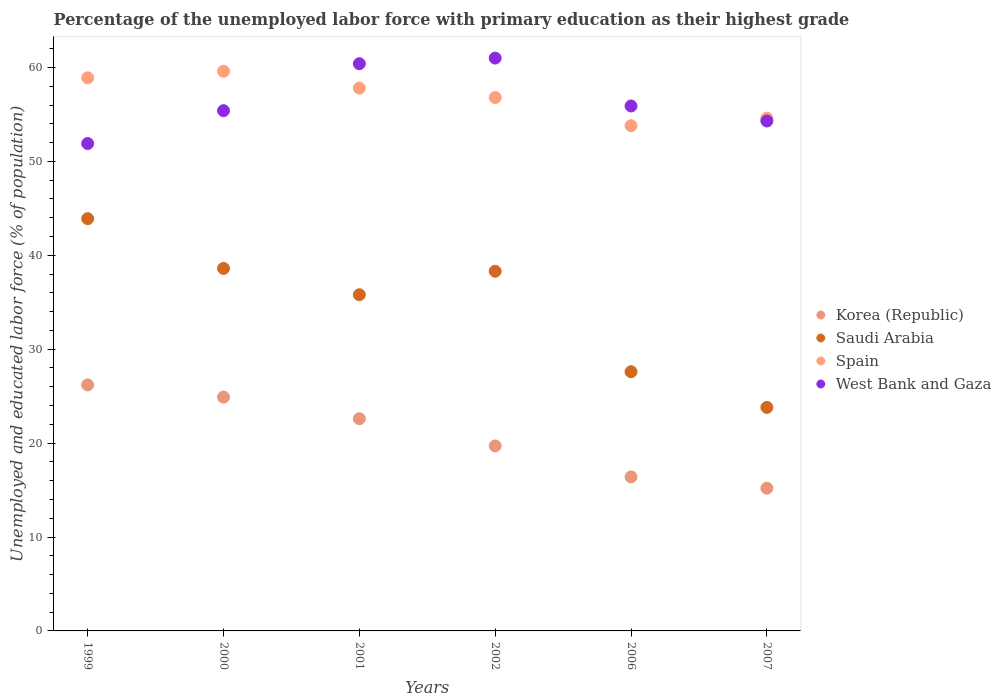Is the number of dotlines equal to the number of legend labels?
Make the answer very short. Yes. What is the percentage of the unemployed labor force with primary education in West Bank and Gaza in 1999?
Provide a short and direct response. 51.9. Across all years, what is the maximum percentage of the unemployed labor force with primary education in Korea (Republic)?
Ensure brevity in your answer.  26.2. Across all years, what is the minimum percentage of the unemployed labor force with primary education in Korea (Republic)?
Ensure brevity in your answer.  15.2. In which year was the percentage of the unemployed labor force with primary education in Korea (Republic) maximum?
Offer a terse response. 1999. What is the total percentage of the unemployed labor force with primary education in Korea (Republic) in the graph?
Offer a terse response. 125. What is the difference between the percentage of the unemployed labor force with primary education in West Bank and Gaza in 1999 and that in 2006?
Your response must be concise. -4. What is the difference between the percentage of the unemployed labor force with primary education in Korea (Republic) in 1999 and the percentage of the unemployed labor force with primary education in Spain in 2000?
Your answer should be very brief. -33.4. What is the average percentage of the unemployed labor force with primary education in West Bank and Gaza per year?
Make the answer very short. 56.48. In the year 2001, what is the difference between the percentage of the unemployed labor force with primary education in Saudi Arabia and percentage of the unemployed labor force with primary education in Korea (Republic)?
Provide a succinct answer. 13.2. In how many years, is the percentage of the unemployed labor force with primary education in West Bank and Gaza greater than 26 %?
Offer a very short reply. 6. What is the ratio of the percentage of the unemployed labor force with primary education in Spain in 1999 to that in 2001?
Keep it short and to the point. 1.02. What is the difference between the highest and the second highest percentage of the unemployed labor force with primary education in Korea (Republic)?
Offer a terse response. 1.3. What is the difference between the highest and the lowest percentage of the unemployed labor force with primary education in Korea (Republic)?
Offer a terse response. 11. In how many years, is the percentage of the unemployed labor force with primary education in West Bank and Gaza greater than the average percentage of the unemployed labor force with primary education in West Bank and Gaza taken over all years?
Provide a short and direct response. 2. Is it the case that in every year, the sum of the percentage of the unemployed labor force with primary education in Korea (Republic) and percentage of the unemployed labor force with primary education in Spain  is greater than the sum of percentage of the unemployed labor force with primary education in Saudi Arabia and percentage of the unemployed labor force with primary education in West Bank and Gaza?
Your answer should be compact. Yes. Does the percentage of the unemployed labor force with primary education in West Bank and Gaza monotonically increase over the years?
Your answer should be compact. No. Does the graph contain any zero values?
Offer a very short reply. No. What is the title of the graph?
Give a very brief answer. Percentage of the unemployed labor force with primary education as their highest grade. Does "Central Europe" appear as one of the legend labels in the graph?
Make the answer very short. No. What is the label or title of the X-axis?
Offer a terse response. Years. What is the label or title of the Y-axis?
Offer a very short reply. Unemployed and educated labor force (% of population). What is the Unemployed and educated labor force (% of population) of Korea (Republic) in 1999?
Provide a succinct answer. 26.2. What is the Unemployed and educated labor force (% of population) in Saudi Arabia in 1999?
Give a very brief answer. 43.9. What is the Unemployed and educated labor force (% of population) of Spain in 1999?
Offer a very short reply. 58.9. What is the Unemployed and educated labor force (% of population) of West Bank and Gaza in 1999?
Provide a short and direct response. 51.9. What is the Unemployed and educated labor force (% of population) in Korea (Republic) in 2000?
Offer a terse response. 24.9. What is the Unemployed and educated labor force (% of population) of Saudi Arabia in 2000?
Your response must be concise. 38.6. What is the Unemployed and educated labor force (% of population) in Spain in 2000?
Offer a very short reply. 59.6. What is the Unemployed and educated labor force (% of population) of West Bank and Gaza in 2000?
Keep it short and to the point. 55.4. What is the Unemployed and educated labor force (% of population) of Korea (Republic) in 2001?
Your answer should be compact. 22.6. What is the Unemployed and educated labor force (% of population) of Saudi Arabia in 2001?
Provide a succinct answer. 35.8. What is the Unemployed and educated labor force (% of population) of Spain in 2001?
Ensure brevity in your answer.  57.8. What is the Unemployed and educated labor force (% of population) of West Bank and Gaza in 2001?
Give a very brief answer. 60.4. What is the Unemployed and educated labor force (% of population) in Korea (Republic) in 2002?
Offer a very short reply. 19.7. What is the Unemployed and educated labor force (% of population) in Saudi Arabia in 2002?
Keep it short and to the point. 38.3. What is the Unemployed and educated labor force (% of population) in Spain in 2002?
Provide a succinct answer. 56.8. What is the Unemployed and educated labor force (% of population) in Korea (Republic) in 2006?
Make the answer very short. 16.4. What is the Unemployed and educated labor force (% of population) of Saudi Arabia in 2006?
Offer a terse response. 27.6. What is the Unemployed and educated labor force (% of population) in Spain in 2006?
Provide a succinct answer. 53.8. What is the Unemployed and educated labor force (% of population) in West Bank and Gaza in 2006?
Your answer should be compact. 55.9. What is the Unemployed and educated labor force (% of population) in Korea (Republic) in 2007?
Offer a very short reply. 15.2. What is the Unemployed and educated labor force (% of population) of Saudi Arabia in 2007?
Offer a terse response. 23.8. What is the Unemployed and educated labor force (% of population) in Spain in 2007?
Ensure brevity in your answer.  54.6. What is the Unemployed and educated labor force (% of population) in West Bank and Gaza in 2007?
Offer a very short reply. 54.3. Across all years, what is the maximum Unemployed and educated labor force (% of population) in Korea (Republic)?
Your answer should be compact. 26.2. Across all years, what is the maximum Unemployed and educated labor force (% of population) in Saudi Arabia?
Provide a succinct answer. 43.9. Across all years, what is the maximum Unemployed and educated labor force (% of population) of Spain?
Make the answer very short. 59.6. Across all years, what is the minimum Unemployed and educated labor force (% of population) in Korea (Republic)?
Keep it short and to the point. 15.2. Across all years, what is the minimum Unemployed and educated labor force (% of population) in Saudi Arabia?
Ensure brevity in your answer.  23.8. Across all years, what is the minimum Unemployed and educated labor force (% of population) in Spain?
Your response must be concise. 53.8. Across all years, what is the minimum Unemployed and educated labor force (% of population) of West Bank and Gaza?
Your answer should be compact. 51.9. What is the total Unemployed and educated labor force (% of population) in Korea (Republic) in the graph?
Provide a succinct answer. 125. What is the total Unemployed and educated labor force (% of population) of Saudi Arabia in the graph?
Provide a short and direct response. 208. What is the total Unemployed and educated labor force (% of population) in Spain in the graph?
Provide a succinct answer. 341.5. What is the total Unemployed and educated labor force (% of population) of West Bank and Gaza in the graph?
Your answer should be very brief. 338.9. What is the difference between the Unemployed and educated labor force (% of population) in Spain in 1999 and that in 2000?
Keep it short and to the point. -0.7. What is the difference between the Unemployed and educated labor force (% of population) of Korea (Republic) in 1999 and that in 2001?
Provide a succinct answer. 3.6. What is the difference between the Unemployed and educated labor force (% of population) of Saudi Arabia in 1999 and that in 2001?
Provide a succinct answer. 8.1. What is the difference between the Unemployed and educated labor force (% of population) of Spain in 1999 and that in 2001?
Your response must be concise. 1.1. What is the difference between the Unemployed and educated labor force (% of population) of West Bank and Gaza in 1999 and that in 2002?
Your answer should be very brief. -9.1. What is the difference between the Unemployed and educated labor force (% of population) of West Bank and Gaza in 1999 and that in 2006?
Give a very brief answer. -4. What is the difference between the Unemployed and educated labor force (% of population) in Korea (Republic) in 1999 and that in 2007?
Your response must be concise. 11. What is the difference between the Unemployed and educated labor force (% of population) of Saudi Arabia in 1999 and that in 2007?
Offer a terse response. 20.1. What is the difference between the Unemployed and educated labor force (% of population) in West Bank and Gaza in 2000 and that in 2001?
Give a very brief answer. -5. What is the difference between the Unemployed and educated labor force (% of population) of Korea (Republic) in 2000 and that in 2002?
Ensure brevity in your answer.  5.2. What is the difference between the Unemployed and educated labor force (% of population) of Saudi Arabia in 2000 and that in 2002?
Your answer should be very brief. 0.3. What is the difference between the Unemployed and educated labor force (% of population) of Spain in 2000 and that in 2006?
Your response must be concise. 5.8. What is the difference between the Unemployed and educated labor force (% of population) of Korea (Republic) in 2000 and that in 2007?
Your answer should be very brief. 9.7. What is the difference between the Unemployed and educated labor force (% of population) of West Bank and Gaza in 2000 and that in 2007?
Give a very brief answer. 1.1. What is the difference between the Unemployed and educated labor force (% of population) in Korea (Republic) in 2001 and that in 2002?
Make the answer very short. 2.9. What is the difference between the Unemployed and educated labor force (% of population) in Saudi Arabia in 2001 and that in 2002?
Your answer should be compact. -2.5. What is the difference between the Unemployed and educated labor force (% of population) in Spain in 2001 and that in 2002?
Your answer should be compact. 1. What is the difference between the Unemployed and educated labor force (% of population) of Korea (Republic) in 2001 and that in 2006?
Ensure brevity in your answer.  6.2. What is the difference between the Unemployed and educated labor force (% of population) in Spain in 2001 and that in 2006?
Your answer should be compact. 4. What is the difference between the Unemployed and educated labor force (% of population) in Saudi Arabia in 2001 and that in 2007?
Give a very brief answer. 12. What is the difference between the Unemployed and educated labor force (% of population) of Spain in 2001 and that in 2007?
Ensure brevity in your answer.  3.2. What is the difference between the Unemployed and educated labor force (% of population) of West Bank and Gaza in 2001 and that in 2007?
Your answer should be very brief. 6.1. What is the difference between the Unemployed and educated labor force (% of population) in Korea (Republic) in 2002 and that in 2006?
Provide a short and direct response. 3.3. What is the difference between the Unemployed and educated labor force (% of population) of Saudi Arabia in 2002 and that in 2006?
Offer a very short reply. 10.7. What is the difference between the Unemployed and educated labor force (% of population) in West Bank and Gaza in 2002 and that in 2006?
Your answer should be very brief. 5.1. What is the difference between the Unemployed and educated labor force (% of population) in Korea (Republic) in 2002 and that in 2007?
Provide a short and direct response. 4.5. What is the difference between the Unemployed and educated labor force (% of population) of West Bank and Gaza in 2002 and that in 2007?
Your answer should be very brief. 6.7. What is the difference between the Unemployed and educated labor force (% of population) in Korea (Republic) in 2006 and that in 2007?
Offer a very short reply. 1.2. What is the difference between the Unemployed and educated labor force (% of population) in Spain in 2006 and that in 2007?
Offer a terse response. -0.8. What is the difference between the Unemployed and educated labor force (% of population) of Korea (Republic) in 1999 and the Unemployed and educated labor force (% of population) of Spain in 2000?
Your response must be concise. -33.4. What is the difference between the Unemployed and educated labor force (% of population) of Korea (Republic) in 1999 and the Unemployed and educated labor force (% of population) of West Bank and Gaza in 2000?
Your answer should be very brief. -29.2. What is the difference between the Unemployed and educated labor force (% of population) of Saudi Arabia in 1999 and the Unemployed and educated labor force (% of population) of Spain in 2000?
Give a very brief answer. -15.7. What is the difference between the Unemployed and educated labor force (% of population) in Korea (Republic) in 1999 and the Unemployed and educated labor force (% of population) in Saudi Arabia in 2001?
Keep it short and to the point. -9.6. What is the difference between the Unemployed and educated labor force (% of population) of Korea (Republic) in 1999 and the Unemployed and educated labor force (% of population) of Spain in 2001?
Give a very brief answer. -31.6. What is the difference between the Unemployed and educated labor force (% of population) in Korea (Republic) in 1999 and the Unemployed and educated labor force (% of population) in West Bank and Gaza in 2001?
Provide a short and direct response. -34.2. What is the difference between the Unemployed and educated labor force (% of population) in Saudi Arabia in 1999 and the Unemployed and educated labor force (% of population) in Spain in 2001?
Provide a succinct answer. -13.9. What is the difference between the Unemployed and educated labor force (% of population) in Saudi Arabia in 1999 and the Unemployed and educated labor force (% of population) in West Bank and Gaza in 2001?
Your response must be concise. -16.5. What is the difference between the Unemployed and educated labor force (% of population) of Spain in 1999 and the Unemployed and educated labor force (% of population) of West Bank and Gaza in 2001?
Provide a short and direct response. -1.5. What is the difference between the Unemployed and educated labor force (% of population) in Korea (Republic) in 1999 and the Unemployed and educated labor force (% of population) in Spain in 2002?
Offer a very short reply. -30.6. What is the difference between the Unemployed and educated labor force (% of population) of Korea (Republic) in 1999 and the Unemployed and educated labor force (% of population) of West Bank and Gaza in 2002?
Offer a terse response. -34.8. What is the difference between the Unemployed and educated labor force (% of population) in Saudi Arabia in 1999 and the Unemployed and educated labor force (% of population) in West Bank and Gaza in 2002?
Your answer should be compact. -17.1. What is the difference between the Unemployed and educated labor force (% of population) in Korea (Republic) in 1999 and the Unemployed and educated labor force (% of population) in Saudi Arabia in 2006?
Your answer should be compact. -1.4. What is the difference between the Unemployed and educated labor force (% of population) in Korea (Republic) in 1999 and the Unemployed and educated labor force (% of population) in Spain in 2006?
Offer a terse response. -27.6. What is the difference between the Unemployed and educated labor force (% of population) in Korea (Republic) in 1999 and the Unemployed and educated labor force (% of population) in West Bank and Gaza in 2006?
Keep it short and to the point. -29.7. What is the difference between the Unemployed and educated labor force (% of population) of Saudi Arabia in 1999 and the Unemployed and educated labor force (% of population) of Spain in 2006?
Give a very brief answer. -9.9. What is the difference between the Unemployed and educated labor force (% of population) in Saudi Arabia in 1999 and the Unemployed and educated labor force (% of population) in West Bank and Gaza in 2006?
Your answer should be compact. -12. What is the difference between the Unemployed and educated labor force (% of population) of Spain in 1999 and the Unemployed and educated labor force (% of population) of West Bank and Gaza in 2006?
Your answer should be compact. 3. What is the difference between the Unemployed and educated labor force (% of population) in Korea (Republic) in 1999 and the Unemployed and educated labor force (% of population) in Saudi Arabia in 2007?
Ensure brevity in your answer.  2.4. What is the difference between the Unemployed and educated labor force (% of population) of Korea (Republic) in 1999 and the Unemployed and educated labor force (% of population) of Spain in 2007?
Keep it short and to the point. -28.4. What is the difference between the Unemployed and educated labor force (% of population) of Korea (Republic) in 1999 and the Unemployed and educated labor force (% of population) of West Bank and Gaza in 2007?
Your response must be concise. -28.1. What is the difference between the Unemployed and educated labor force (% of population) in Saudi Arabia in 1999 and the Unemployed and educated labor force (% of population) in West Bank and Gaza in 2007?
Ensure brevity in your answer.  -10.4. What is the difference between the Unemployed and educated labor force (% of population) of Korea (Republic) in 2000 and the Unemployed and educated labor force (% of population) of Spain in 2001?
Make the answer very short. -32.9. What is the difference between the Unemployed and educated labor force (% of population) of Korea (Republic) in 2000 and the Unemployed and educated labor force (% of population) of West Bank and Gaza in 2001?
Keep it short and to the point. -35.5. What is the difference between the Unemployed and educated labor force (% of population) in Saudi Arabia in 2000 and the Unemployed and educated labor force (% of population) in Spain in 2001?
Your answer should be compact. -19.2. What is the difference between the Unemployed and educated labor force (% of population) of Saudi Arabia in 2000 and the Unemployed and educated labor force (% of population) of West Bank and Gaza in 2001?
Keep it short and to the point. -21.8. What is the difference between the Unemployed and educated labor force (% of population) in Korea (Republic) in 2000 and the Unemployed and educated labor force (% of population) in Saudi Arabia in 2002?
Your response must be concise. -13.4. What is the difference between the Unemployed and educated labor force (% of population) of Korea (Republic) in 2000 and the Unemployed and educated labor force (% of population) of Spain in 2002?
Your answer should be very brief. -31.9. What is the difference between the Unemployed and educated labor force (% of population) in Korea (Republic) in 2000 and the Unemployed and educated labor force (% of population) in West Bank and Gaza in 2002?
Provide a short and direct response. -36.1. What is the difference between the Unemployed and educated labor force (% of population) of Saudi Arabia in 2000 and the Unemployed and educated labor force (% of population) of Spain in 2002?
Make the answer very short. -18.2. What is the difference between the Unemployed and educated labor force (% of population) in Saudi Arabia in 2000 and the Unemployed and educated labor force (% of population) in West Bank and Gaza in 2002?
Offer a terse response. -22.4. What is the difference between the Unemployed and educated labor force (% of population) of Spain in 2000 and the Unemployed and educated labor force (% of population) of West Bank and Gaza in 2002?
Your answer should be very brief. -1.4. What is the difference between the Unemployed and educated labor force (% of population) of Korea (Republic) in 2000 and the Unemployed and educated labor force (% of population) of Saudi Arabia in 2006?
Make the answer very short. -2.7. What is the difference between the Unemployed and educated labor force (% of population) of Korea (Republic) in 2000 and the Unemployed and educated labor force (% of population) of Spain in 2006?
Ensure brevity in your answer.  -28.9. What is the difference between the Unemployed and educated labor force (% of population) in Korea (Republic) in 2000 and the Unemployed and educated labor force (% of population) in West Bank and Gaza in 2006?
Give a very brief answer. -31. What is the difference between the Unemployed and educated labor force (% of population) of Saudi Arabia in 2000 and the Unemployed and educated labor force (% of population) of Spain in 2006?
Ensure brevity in your answer.  -15.2. What is the difference between the Unemployed and educated labor force (% of population) of Saudi Arabia in 2000 and the Unemployed and educated labor force (% of population) of West Bank and Gaza in 2006?
Provide a short and direct response. -17.3. What is the difference between the Unemployed and educated labor force (% of population) of Spain in 2000 and the Unemployed and educated labor force (% of population) of West Bank and Gaza in 2006?
Make the answer very short. 3.7. What is the difference between the Unemployed and educated labor force (% of population) in Korea (Republic) in 2000 and the Unemployed and educated labor force (% of population) in Spain in 2007?
Your response must be concise. -29.7. What is the difference between the Unemployed and educated labor force (% of population) of Korea (Republic) in 2000 and the Unemployed and educated labor force (% of population) of West Bank and Gaza in 2007?
Make the answer very short. -29.4. What is the difference between the Unemployed and educated labor force (% of population) in Saudi Arabia in 2000 and the Unemployed and educated labor force (% of population) in Spain in 2007?
Give a very brief answer. -16. What is the difference between the Unemployed and educated labor force (% of population) in Saudi Arabia in 2000 and the Unemployed and educated labor force (% of population) in West Bank and Gaza in 2007?
Provide a short and direct response. -15.7. What is the difference between the Unemployed and educated labor force (% of population) in Korea (Republic) in 2001 and the Unemployed and educated labor force (% of population) in Saudi Arabia in 2002?
Keep it short and to the point. -15.7. What is the difference between the Unemployed and educated labor force (% of population) in Korea (Republic) in 2001 and the Unemployed and educated labor force (% of population) in Spain in 2002?
Ensure brevity in your answer.  -34.2. What is the difference between the Unemployed and educated labor force (% of population) of Korea (Republic) in 2001 and the Unemployed and educated labor force (% of population) of West Bank and Gaza in 2002?
Make the answer very short. -38.4. What is the difference between the Unemployed and educated labor force (% of population) in Saudi Arabia in 2001 and the Unemployed and educated labor force (% of population) in Spain in 2002?
Your response must be concise. -21. What is the difference between the Unemployed and educated labor force (% of population) in Saudi Arabia in 2001 and the Unemployed and educated labor force (% of population) in West Bank and Gaza in 2002?
Your answer should be very brief. -25.2. What is the difference between the Unemployed and educated labor force (% of population) of Spain in 2001 and the Unemployed and educated labor force (% of population) of West Bank and Gaza in 2002?
Your response must be concise. -3.2. What is the difference between the Unemployed and educated labor force (% of population) in Korea (Republic) in 2001 and the Unemployed and educated labor force (% of population) in Saudi Arabia in 2006?
Give a very brief answer. -5. What is the difference between the Unemployed and educated labor force (% of population) of Korea (Republic) in 2001 and the Unemployed and educated labor force (% of population) of Spain in 2006?
Offer a terse response. -31.2. What is the difference between the Unemployed and educated labor force (% of population) in Korea (Republic) in 2001 and the Unemployed and educated labor force (% of population) in West Bank and Gaza in 2006?
Ensure brevity in your answer.  -33.3. What is the difference between the Unemployed and educated labor force (% of population) in Saudi Arabia in 2001 and the Unemployed and educated labor force (% of population) in Spain in 2006?
Ensure brevity in your answer.  -18. What is the difference between the Unemployed and educated labor force (% of population) of Saudi Arabia in 2001 and the Unemployed and educated labor force (% of population) of West Bank and Gaza in 2006?
Give a very brief answer. -20.1. What is the difference between the Unemployed and educated labor force (% of population) in Korea (Republic) in 2001 and the Unemployed and educated labor force (% of population) in Saudi Arabia in 2007?
Your answer should be compact. -1.2. What is the difference between the Unemployed and educated labor force (% of population) of Korea (Republic) in 2001 and the Unemployed and educated labor force (% of population) of Spain in 2007?
Your answer should be very brief. -32. What is the difference between the Unemployed and educated labor force (% of population) of Korea (Republic) in 2001 and the Unemployed and educated labor force (% of population) of West Bank and Gaza in 2007?
Offer a very short reply. -31.7. What is the difference between the Unemployed and educated labor force (% of population) of Saudi Arabia in 2001 and the Unemployed and educated labor force (% of population) of Spain in 2007?
Provide a short and direct response. -18.8. What is the difference between the Unemployed and educated labor force (% of population) of Saudi Arabia in 2001 and the Unemployed and educated labor force (% of population) of West Bank and Gaza in 2007?
Keep it short and to the point. -18.5. What is the difference between the Unemployed and educated labor force (% of population) of Korea (Republic) in 2002 and the Unemployed and educated labor force (% of population) of Spain in 2006?
Offer a terse response. -34.1. What is the difference between the Unemployed and educated labor force (% of population) of Korea (Republic) in 2002 and the Unemployed and educated labor force (% of population) of West Bank and Gaza in 2006?
Your answer should be very brief. -36.2. What is the difference between the Unemployed and educated labor force (% of population) of Saudi Arabia in 2002 and the Unemployed and educated labor force (% of population) of Spain in 2006?
Make the answer very short. -15.5. What is the difference between the Unemployed and educated labor force (% of population) in Saudi Arabia in 2002 and the Unemployed and educated labor force (% of population) in West Bank and Gaza in 2006?
Ensure brevity in your answer.  -17.6. What is the difference between the Unemployed and educated labor force (% of population) of Spain in 2002 and the Unemployed and educated labor force (% of population) of West Bank and Gaza in 2006?
Give a very brief answer. 0.9. What is the difference between the Unemployed and educated labor force (% of population) of Korea (Republic) in 2002 and the Unemployed and educated labor force (% of population) of Saudi Arabia in 2007?
Your response must be concise. -4.1. What is the difference between the Unemployed and educated labor force (% of population) of Korea (Republic) in 2002 and the Unemployed and educated labor force (% of population) of Spain in 2007?
Offer a terse response. -34.9. What is the difference between the Unemployed and educated labor force (% of population) of Korea (Republic) in 2002 and the Unemployed and educated labor force (% of population) of West Bank and Gaza in 2007?
Provide a succinct answer. -34.6. What is the difference between the Unemployed and educated labor force (% of population) in Saudi Arabia in 2002 and the Unemployed and educated labor force (% of population) in Spain in 2007?
Provide a succinct answer. -16.3. What is the difference between the Unemployed and educated labor force (% of population) in Saudi Arabia in 2002 and the Unemployed and educated labor force (% of population) in West Bank and Gaza in 2007?
Ensure brevity in your answer.  -16. What is the difference between the Unemployed and educated labor force (% of population) in Korea (Republic) in 2006 and the Unemployed and educated labor force (% of population) in Saudi Arabia in 2007?
Ensure brevity in your answer.  -7.4. What is the difference between the Unemployed and educated labor force (% of population) in Korea (Republic) in 2006 and the Unemployed and educated labor force (% of population) in Spain in 2007?
Provide a short and direct response. -38.2. What is the difference between the Unemployed and educated labor force (% of population) in Korea (Republic) in 2006 and the Unemployed and educated labor force (% of population) in West Bank and Gaza in 2007?
Provide a short and direct response. -37.9. What is the difference between the Unemployed and educated labor force (% of population) of Saudi Arabia in 2006 and the Unemployed and educated labor force (% of population) of Spain in 2007?
Ensure brevity in your answer.  -27. What is the difference between the Unemployed and educated labor force (% of population) of Saudi Arabia in 2006 and the Unemployed and educated labor force (% of population) of West Bank and Gaza in 2007?
Your answer should be compact. -26.7. What is the difference between the Unemployed and educated labor force (% of population) in Spain in 2006 and the Unemployed and educated labor force (% of population) in West Bank and Gaza in 2007?
Provide a succinct answer. -0.5. What is the average Unemployed and educated labor force (% of population) in Korea (Republic) per year?
Keep it short and to the point. 20.83. What is the average Unemployed and educated labor force (% of population) of Saudi Arabia per year?
Offer a very short reply. 34.67. What is the average Unemployed and educated labor force (% of population) in Spain per year?
Offer a terse response. 56.92. What is the average Unemployed and educated labor force (% of population) in West Bank and Gaza per year?
Your answer should be very brief. 56.48. In the year 1999, what is the difference between the Unemployed and educated labor force (% of population) in Korea (Republic) and Unemployed and educated labor force (% of population) in Saudi Arabia?
Your answer should be very brief. -17.7. In the year 1999, what is the difference between the Unemployed and educated labor force (% of population) in Korea (Republic) and Unemployed and educated labor force (% of population) in Spain?
Your answer should be compact. -32.7. In the year 1999, what is the difference between the Unemployed and educated labor force (% of population) of Korea (Republic) and Unemployed and educated labor force (% of population) of West Bank and Gaza?
Give a very brief answer. -25.7. In the year 1999, what is the difference between the Unemployed and educated labor force (% of population) of Saudi Arabia and Unemployed and educated labor force (% of population) of West Bank and Gaza?
Offer a very short reply. -8. In the year 1999, what is the difference between the Unemployed and educated labor force (% of population) in Spain and Unemployed and educated labor force (% of population) in West Bank and Gaza?
Give a very brief answer. 7. In the year 2000, what is the difference between the Unemployed and educated labor force (% of population) in Korea (Republic) and Unemployed and educated labor force (% of population) in Saudi Arabia?
Your response must be concise. -13.7. In the year 2000, what is the difference between the Unemployed and educated labor force (% of population) in Korea (Republic) and Unemployed and educated labor force (% of population) in Spain?
Keep it short and to the point. -34.7. In the year 2000, what is the difference between the Unemployed and educated labor force (% of population) in Korea (Republic) and Unemployed and educated labor force (% of population) in West Bank and Gaza?
Your answer should be very brief. -30.5. In the year 2000, what is the difference between the Unemployed and educated labor force (% of population) in Saudi Arabia and Unemployed and educated labor force (% of population) in Spain?
Provide a short and direct response. -21. In the year 2000, what is the difference between the Unemployed and educated labor force (% of population) in Saudi Arabia and Unemployed and educated labor force (% of population) in West Bank and Gaza?
Your response must be concise. -16.8. In the year 2001, what is the difference between the Unemployed and educated labor force (% of population) of Korea (Republic) and Unemployed and educated labor force (% of population) of Saudi Arabia?
Provide a short and direct response. -13.2. In the year 2001, what is the difference between the Unemployed and educated labor force (% of population) of Korea (Republic) and Unemployed and educated labor force (% of population) of Spain?
Your answer should be very brief. -35.2. In the year 2001, what is the difference between the Unemployed and educated labor force (% of population) in Korea (Republic) and Unemployed and educated labor force (% of population) in West Bank and Gaza?
Give a very brief answer. -37.8. In the year 2001, what is the difference between the Unemployed and educated labor force (% of population) in Saudi Arabia and Unemployed and educated labor force (% of population) in Spain?
Offer a terse response. -22. In the year 2001, what is the difference between the Unemployed and educated labor force (% of population) of Saudi Arabia and Unemployed and educated labor force (% of population) of West Bank and Gaza?
Keep it short and to the point. -24.6. In the year 2002, what is the difference between the Unemployed and educated labor force (% of population) of Korea (Republic) and Unemployed and educated labor force (% of population) of Saudi Arabia?
Provide a short and direct response. -18.6. In the year 2002, what is the difference between the Unemployed and educated labor force (% of population) of Korea (Republic) and Unemployed and educated labor force (% of population) of Spain?
Your answer should be very brief. -37.1. In the year 2002, what is the difference between the Unemployed and educated labor force (% of population) in Korea (Republic) and Unemployed and educated labor force (% of population) in West Bank and Gaza?
Provide a short and direct response. -41.3. In the year 2002, what is the difference between the Unemployed and educated labor force (% of population) in Saudi Arabia and Unemployed and educated labor force (% of population) in Spain?
Offer a terse response. -18.5. In the year 2002, what is the difference between the Unemployed and educated labor force (% of population) of Saudi Arabia and Unemployed and educated labor force (% of population) of West Bank and Gaza?
Your response must be concise. -22.7. In the year 2006, what is the difference between the Unemployed and educated labor force (% of population) of Korea (Republic) and Unemployed and educated labor force (% of population) of Saudi Arabia?
Make the answer very short. -11.2. In the year 2006, what is the difference between the Unemployed and educated labor force (% of population) of Korea (Republic) and Unemployed and educated labor force (% of population) of Spain?
Your answer should be very brief. -37.4. In the year 2006, what is the difference between the Unemployed and educated labor force (% of population) in Korea (Republic) and Unemployed and educated labor force (% of population) in West Bank and Gaza?
Your answer should be compact. -39.5. In the year 2006, what is the difference between the Unemployed and educated labor force (% of population) of Saudi Arabia and Unemployed and educated labor force (% of population) of Spain?
Provide a succinct answer. -26.2. In the year 2006, what is the difference between the Unemployed and educated labor force (% of population) of Saudi Arabia and Unemployed and educated labor force (% of population) of West Bank and Gaza?
Ensure brevity in your answer.  -28.3. In the year 2006, what is the difference between the Unemployed and educated labor force (% of population) of Spain and Unemployed and educated labor force (% of population) of West Bank and Gaza?
Your response must be concise. -2.1. In the year 2007, what is the difference between the Unemployed and educated labor force (% of population) of Korea (Republic) and Unemployed and educated labor force (% of population) of Spain?
Provide a short and direct response. -39.4. In the year 2007, what is the difference between the Unemployed and educated labor force (% of population) in Korea (Republic) and Unemployed and educated labor force (% of population) in West Bank and Gaza?
Offer a terse response. -39.1. In the year 2007, what is the difference between the Unemployed and educated labor force (% of population) of Saudi Arabia and Unemployed and educated labor force (% of population) of Spain?
Your response must be concise. -30.8. In the year 2007, what is the difference between the Unemployed and educated labor force (% of population) of Saudi Arabia and Unemployed and educated labor force (% of population) of West Bank and Gaza?
Give a very brief answer. -30.5. In the year 2007, what is the difference between the Unemployed and educated labor force (% of population) of Spain and Unemployed and educated labor force (% of population) of West Bank and Gaza?
Offer a very short reply. 0.3. What is the ratio of the Unemployed and educated labor force (% of population) in Korea (Republic) in 1999 to that in 2000?
Keep it short and to the point. 1.05. What is the ratio of the Unemployed and educated labor force (% of population) of Saudi Arabia in 1999 to that in 2000?
Provide a short and direct response. 1.14. What is the ratio of the Unemployed and educated labor force (% of population) in Spain in 1999 to that in 2000?
Provide a short and direct response. 0.99. What is the ratio of the Unemployed and educated labor force (% of population) of West Bank and Gaza in 1999 to that in 2000?
Make the answer very short. 0.94. What is the ratio of the Unemployed and educated labor force (% of population) in Korea (Republic) in 1999 to that in 2001?
Offer a terse response. 1.16. What is the ratio of the Unemployed and educated labor force (% of population) of Saudi Arabia in 1999 to that in 2001?
Provide a short and direct response. 1.23. What is the ratio of the Unemployed and educated labor force (% of population) of Spain in 1999 to that in 2001?
Provide a short and direct response. 1.02. What is the ratio of the Unemployed and educated labor force (% of population) in West Bank and Gaza in 1999 to that in 2001?
Offer a terse response. 0.86. What is the ratio of the Unemployed and educated labor force (% of population) of Korea (Republic) in 1999 to that in 2002?
Your answer should be very brief. 1.33. What is the ratio of the Unemployed and educated labor force (% of population) of Saudi Arabia in 1999 to that in 2002?
Offer a terse response. 1.15. What is the ratio of the Unemployed and educated labor force (% of population) in Spain in 1999 to that in 2002?
Provide a short and direct response. 1.04. What is the ratio of the Unemployed and educated labor force (% of population) in West Bank and Gaza in 1999 to that in 2002?
Provide a short and direct response. 0.85. What is the ratio of the Unemployed and educated labor force (% of population) of Korea (Republic) in 1999 to that in 2006?
Provide a short and direct response. 1.6. What is the ratio of the Unemployed and educated labor force (% of population) in Saudi Arabia in 1999 to that in 2006?
Your answer should be compact. 1.59. What is the ratio of the Unemployed and educated labor force (% of population) in Spain in 1999 to that in 2006?
Make the answer very short. 1.09. What is the ratio of the Unemployed and educated labor force (% of population) of West Bank and Gaza in 1999 to that in 2006?
Offer a very short reply. 0.93. What is the ratio of the Unemployed and educated labor force (% of population) of Korea (Republic) in 1999 to that in 2007?
Provide a short and direct response. 1.72. What is the ratio of the Unemployed and educated labor force (% of population) in Saudi Arabia in 1999 to that in 2007?
Ensure brevity in your answer.  1.84. What is the ratio of the Unemployed and educated labor force (% of population) in Spain in 1999 to that in 2007?
Make the answer very short. 1.08. What is the ratio of the Unemployed and educated labor force (% of population) in West Bank and Gaza in 1999 to that in 2007?
Offer a terse response. 0.96. What is the ratio of the Unemployed and educated labor force (% of population) of Korea (Republic) in 2000 to that in 2001?
Provide a short and direct response. 1.1. What is the ratio of the Unemployed and educated labor force (% of population) in Saudi Arabia in 2000 to that in 2001?
Offer a terse response. 1.08. What is the ratio of the Unemployed and educated labor force (% of population) of Spain in 2000 to that in 2001?
Provide a short and direct response. 1.03. What is the ratio of the Unemployed and educated labor force (% of population) in West Bank and Gaza in 2000 to that in 2001?
Ensure brevity in your answer.  0.92. What is the ratio of the Unemployed and educated labor force (% of population) of Korea (Republic) in 2000 to that in 2002?
Keep it short and to the point. 1.26. What is the ratio of the Unemployed and educated labor force (% of population) in Spain in 2000 to that in 2002?
Your answer should be very brief. 1.05. What is the ratio of the Unemployed and educated labor force (% of population) of West Bank and Gaza in 2000 to that in 2002?
Make the answer very short. 0.91. What is the ratio of the Unemployed and educated labor force (% of population) of Korea (Republic) in 2000 to that in 2006?
Offer a very short reply. 1.52. What is the ratio of the Unemployed and educated labor force (% of population) of Saudi Arabia in 2000 to that in 2006?
Provide a succinct answer. 1.4. What is the ratio of the Unemployed and educated labor force (% of population) in Spain in 2000 to that in 2006?
Give a very brief answer. 1.11. What is the ratio of the Unemployed and educated labor force (% of population) in West Bank and Gaza in 2000 to that in 2006?
Your response must be concise. 0.99. What is the ratio of the Unemployed and educated labor force (% of population) of Korea (Republic) in 2000 to that in 2007?
Keep it short and to the point. 1.64. What is the ratio of the Unemployed and educated labor force (% of population) of Saudi Arabia in 2000 to that in 2007?
Offer a very short reply. 1.62. What is the ratio of the Unemployed and educated labor force (% of population) of Spain in 2000 to that in 2007?
Ensure brevity in your answer.  1.09. What is the ratio of the Unemployed and educated labor force (% of population) in West Bank and Gaza in 2000 to that in 2007?
Give a very brief answer. 1.02. What is the ratio of the Unemployed and educated labor force (% of population) in Korea (Republic) in 2001 to that in 2002?
Keep it short and to the point. 1.15. What is the ratio of the Unemployed and educated labor force (% of population) in Saudi Arabia in 2001 to that in 2002?
Your response must be concise. 0.93. What is the ratio of the Unemployed and educated labor force (% of population) of Spain in 2001 to that in 2002?
Provide a short and direct response. 1.02. What is the ratio of the Unemployed and educated labor force (% of population) of West Bank and Gaza in 2001 to that in 2002?
Your response must be concise. 0.99. What is the ratio of the Unemployed and educated labor force (% of population) of Korea (Republic) in 2001 to that in 2006?
Your answer should be compact. 1.38. What is the ratio of the Unemployed and educated labor force (% of population) in Saudi Arabia in 2001 to that in 2006?
Offer a very short reply. 1.3. What is the ratio of the Unemployed and educated labor force (% of population) of Spain in 2001 to that in 2006?
Your response must be concise. 1.07. What is the ratio of the Unemployed and educated labor force (% of population) in West Bank and Gaza in 2001 to that in 2006?
Provide a short and direct response. 1.08. What is the ratio of the Unemployed and educated labor force (% of population) in Korea (Republic) in 2001 to that in 2007?
Provide a succinct answer. 1.49. What is the ratio of the Unemployed and educated labor force (% of population) of Saudi Arabia in 2001 to that in 2007?
Offer a terse response. 1.5. What is the ratio of the Unemployed and educated labor force (% of population) in Spain in 2001 to that in 2007?
Keep it short and to the point. 1.06. What is the ratio of the Unemployed and educated labor force (% of population) of West Bank and Gaza in 2001 to that in 2007?
Offer a terse response. 1.11. What is the ratio of the Unemployed and educated labor force (% of population) in Korea (Republic) in 2002 to that in 2006?
Make the answer very short. 1.2. What is the ratio of the Unemployed and educated labor force (% of population) in Saudi Arabia in 2002 to that in 2006?
Keep it short and to the point. 1.39. What is the ratio of the Unemployed and educated labor force (% of population) of Spain in 2002 to that in 2006?
Provide a succinct answer. 1.06. What is the ratio of the Unemployed and educated labor force (% of population) of West Bank and Gaza in 2002 to that in 2006?
Offer a very short reply. 1.09. What is the ratio of the Unemployed and educated labor force (% of population) of Korea (Republic) in 2002 to that in 2007?
Offer a terse response. 1.3. What is the ratio of the Unemployed and educated labor force (% of population) in Saudi Arabia in 2002 to that in 2007?
Provide a short and direct response. 1.61. What is the ratio of the Unemployed and educated labor force (% of population) of Spain in 2002 to that in 2007?
Make the answer very short. 1.04. What is the ratio of the Unemployed and educated labor force (% of population) of West Bank and Gaza in 2002 to that in 2007?
Keep it short and to the point. 1.12. What is the ratio of the Unemployed and educated labor force (% of population) in Korea (Republic) in 2006 to that in 2007?
Your answer should be compact. 1.08. What is the ratio of the Unemployed and educated labor force (% of population) in Saudi Arabia in 2006 to that in 2007?
Your answer should be compact. 1.16. What is the ratio of the Unemployed and educated labor force (% of population) of West Bank and Gaza in 2006 to that in 2007?
Give a very brief answer. 1.03. What is the difference between the highest and the second highest Unemployed and educated labor force (% of population) of Korea (Republic)?
Offer a very short reply. 1.3. What is the difference between the highest and the second highest Unemployed and educated labor force (% of population) in Saudi Arabia?
Your response must be concise. 5.3. What is the difference between the highest and the second highest Unemployed and educated labor force (% of population) of West Bank and Gaza?
Provide a succinct answer. 0.6. What is the difference between the highest and the lowest Unemployed and educated labor force (% of population) in Korea (Republic)?
Keep it short and to the point. 11. What is the difference between the highest and the lowest Unemployed and educated labor force (% of population) of Saudi Arabia?
Provide a short and direct response. 20.1. 